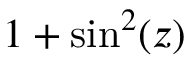<formula> <loc_0><loc_0><loc_500><loc_500>1 + \sin ^ { 2 } ( z )</formula> 